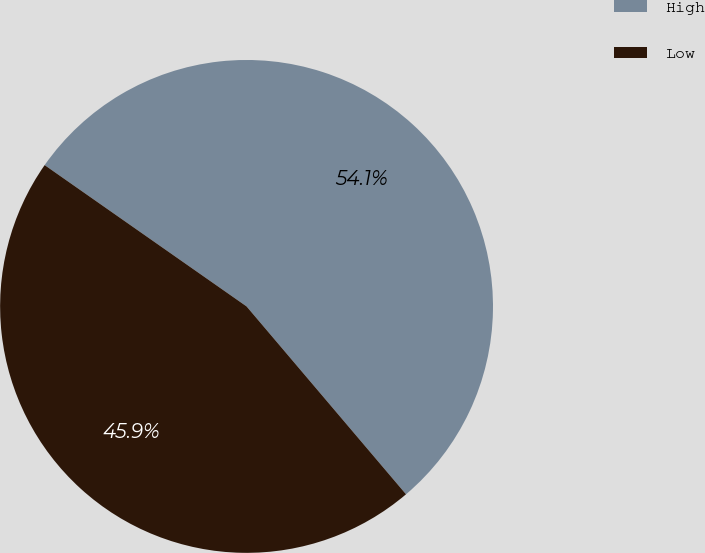<chart> <loc_0><loc_0><loc_500><loc_500><pie_chart><fcel>High<fcel>Low<nl><fcel>54.08%<fcel>45.92%<nl></chart> 